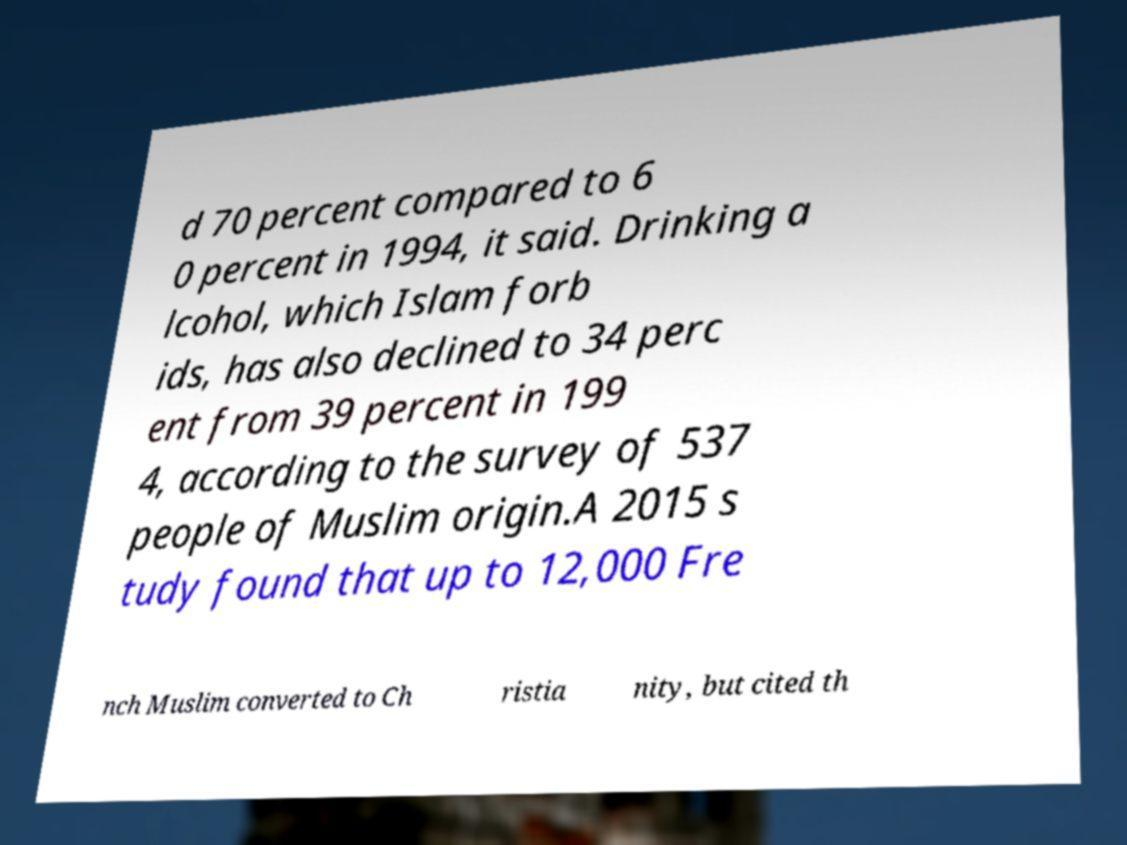Can you read and provide the text displayed in the image?This photo seems to have some interesting text. Can you extract and type it out for me? d 70 percent compared to 6 0 percent in 1994, it said. Drinking a lcohol, which Islam forb ids, has also declined to 34 perc ent from 39 percent in 199 4, according to the survey of 537 people of Muslim origin.A 2015 s tudy found that up to 12,000 Fre nch Muslim converted to Ch ristia nity, but cited th 